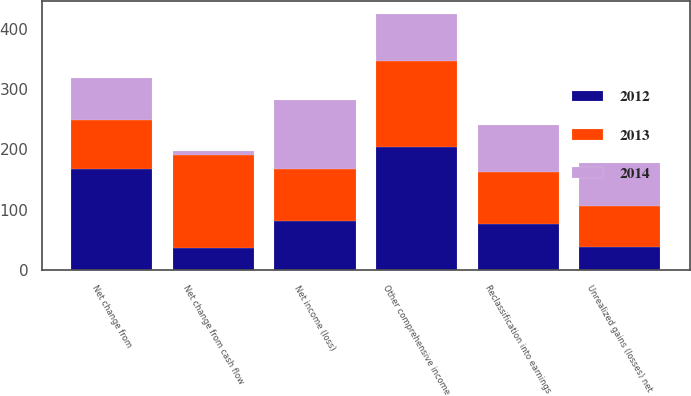<chart> <loc_0><loc_0><loc_500><loc_500><stacked_bar_chart><ecel><fcel>Net income (loss)<fcel>Unrealized gains (losses) net<fcel>Reclassification into earnings<fcel>Net change from<fcel>Net change from cash flow<fcel>Other comprehensive income<nl><fcel>2012<fcel>82<fcel>39<fcel>76<fcel>167<fcel>37<fcel>204<nl><fcel>2013<fcel>86<fcel>67<fcel>87<fcel>82<fcel>154<fcel>143<nl><fcel>2014<fcel>113<fcel>72<fcel>78<fcel>69<fcel>6<fcel>77<nl></chart> 